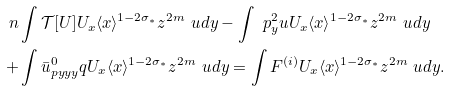Convert formula to latex. <formula><loc_0><loc_0><loc_500><loc_500>\ n & \int \mathcal { T } [ U ] U _ { x } \langle x \rangle ^ { 1 - 2 \sigma _ { \ast } } z ^ { 2 m } \ u d y - \int \ p _ { y } ^ { 2 } u U _ { x } \langle x \rangle ^ { 1 - 2 \sigma _ { \ast } } z ^ { 2 m } \ u d y \\ + & \int \bar { u } ^ { 0 } _ { p y y y } q U _ { x } \langle x \rangle ^ { 1 - 2 \sigma _ { \ast } } z ^ { 2 m } \ u d y = \int F ^ { ( i ) } U _ { x } \langle x \rangle ^ { 1 - 2 \sigma _ { \ast } } z ^ { 2 m } \ u d y .</formula> 